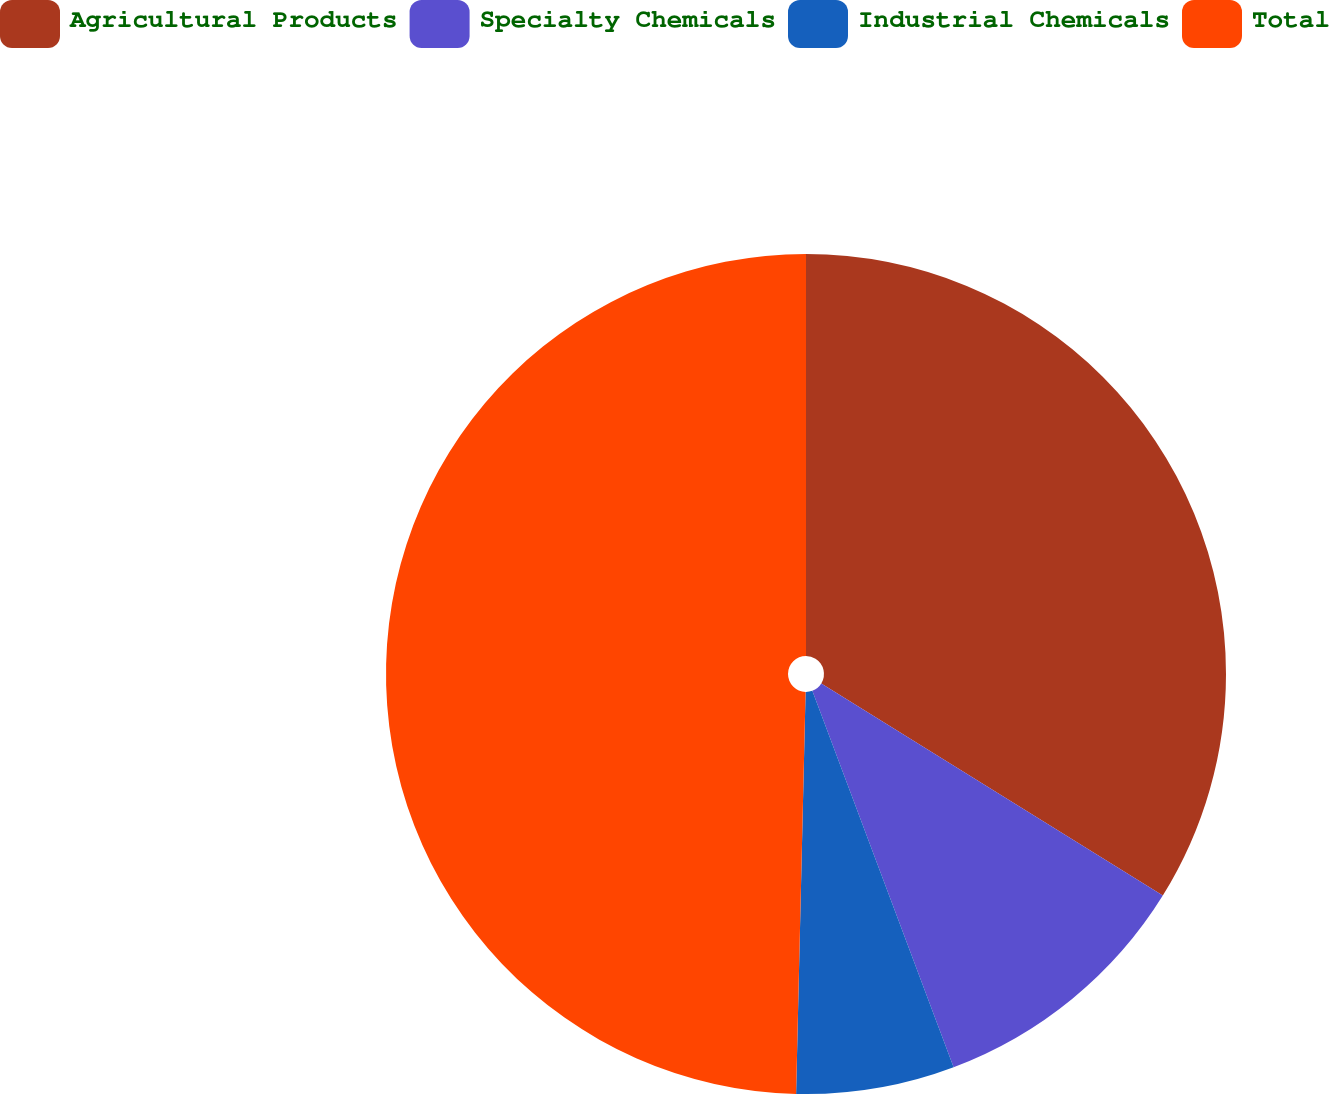Convert chart. <chart><loc_0><loc_0><loc_500><loc_500><pie_chart><fcel>Agricultural Products<fcel>Specialty Chemicals<fcel>Industrial Chemicals<fcel>Total<nl><fcel>33.84%<fcel>10.44%<fcel>6.09%<fcel>49.62%<nl></chart> 